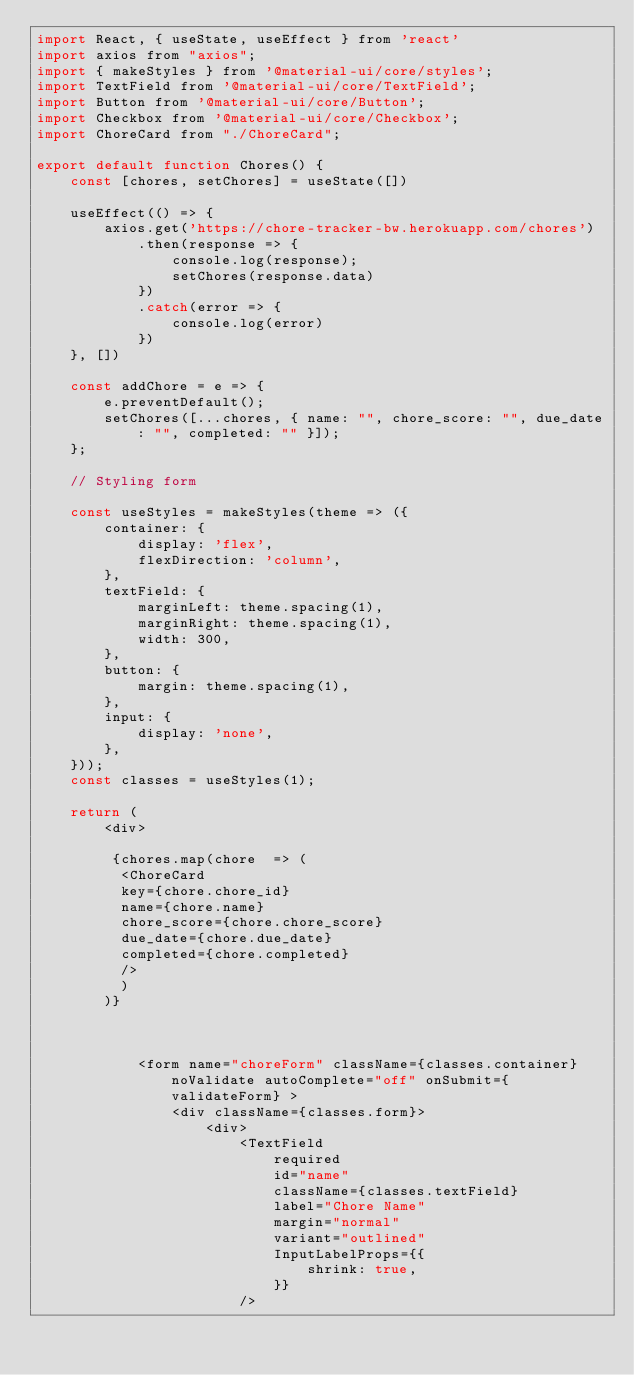<code> <loc_0><loc_0><loc_500><loc_500><_JavaScript_>import React, { useState, useEffect } from 'react'
import axios from "axios";
import { makeStyles } from '@material-ui/core/styles';
import TextField from '@material-ui/core/TextField';
import Button from '@material-ui/core/Button';
import Checkbox from '@material-ui/core/Checkbox';
import ChoreCard from "./ChoreCard";

export default function Chores() {
    const [chores, setChores] = useState([])

    useEffect(() => {
        axios.get('https://chore-tracker-bw.herokuapp.com/chores')
            .then(response => {
                console.log(response);
                setChores(response.data)
            })
            .catch(error => {
                console.log(error)
            })
    }, [])

    const addChore = e => {
        e.preventDefault();
        setChores([...chores, { name: "", chore_score: "", due_date: "", completed: "" }]);
    };

    // Styling form

    const useStyles = makeStyles(theme => ({
        container: {
            display: 'flex',
            flexDirection: 'column',
        },
        textField: {
            marginLeft: theme.spacing(1),
            marginRight: theme.spacing(1),
            width: 300,
        },
        button: {
            margin: theme.spacing(1),
        },
        input: {
            display: 'none',
        },
    }));
    const classes = useStyles(1);

    return (
        <div>
            
         {chores.map(chore  => (
          <ChoreCard  
          key={chore.chore_id} 
          name={chore.name}
          chore_score={chore.chore_score}
          due_date={chore.due_date}
          completed={chore.completed}
          />
          )
        )}



            <form name="choreForm" className={classes.container} noValidate autoComplete="off" onSubmit={validateForm} >
                <div className={classes.form}>
                    <div>
                        <TextField
                            required
                            id="name"
                            className={classes.textField}
                            label="Chore Name"
                            margin="normal"
                            variant="outlined"
                            InputLabelProps={{
                                shrink: true,
                            }}
                        /></code> 